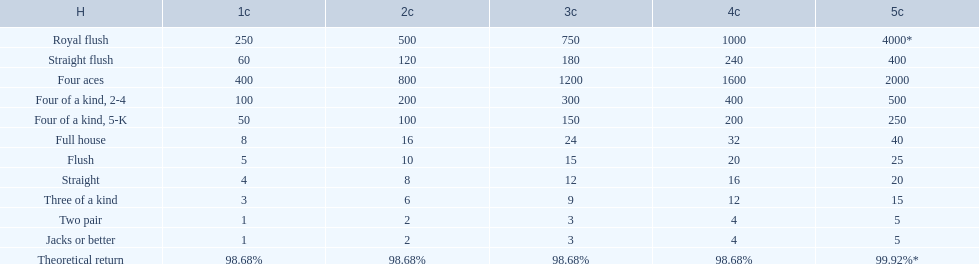What is the values in the 5 credits area? 4000*, 400, 2000, 500, 250, 40, 25, 20, 15, 5, 5. Which of these is for a four of a kind? 500, 250. What is the higher value? 500. Could you parse the entire table as a dict? {'header': ['H', '1c', '2c', '3c', '4c', '5c'], 'rows': [['Royal flush', '250', '500', '750', '1000', '4000*'], ['Straight flush', '60', '120', '180', '240', '400'], ['Four aces', '400', '800', '1200', '1600', '2000'], ['Four of a kind, 2-4', '100', '200', '300', '400', '500'], ['Four of a kind, 5-K', '50', '100', '150', '200', '250'], ['Full house', '8', '16', '24', '32', '40'], ['Flush', '5', '10', '15', '20', '25'], ['Straight', '4', '8', '12', '16', '20'], ['Three of a kind', '3', '6', '9', '12', '15'], ['Two pair', '1', '2', '3', '4', '5'], ['Jacks or better', '1', '2', '3', '4', '5'], ['Theoretical return', '98.68%', '98.68%', '98.68%', '98.68%', '99.92%*']]} What hand is this for Four of a kind, 2-4. 